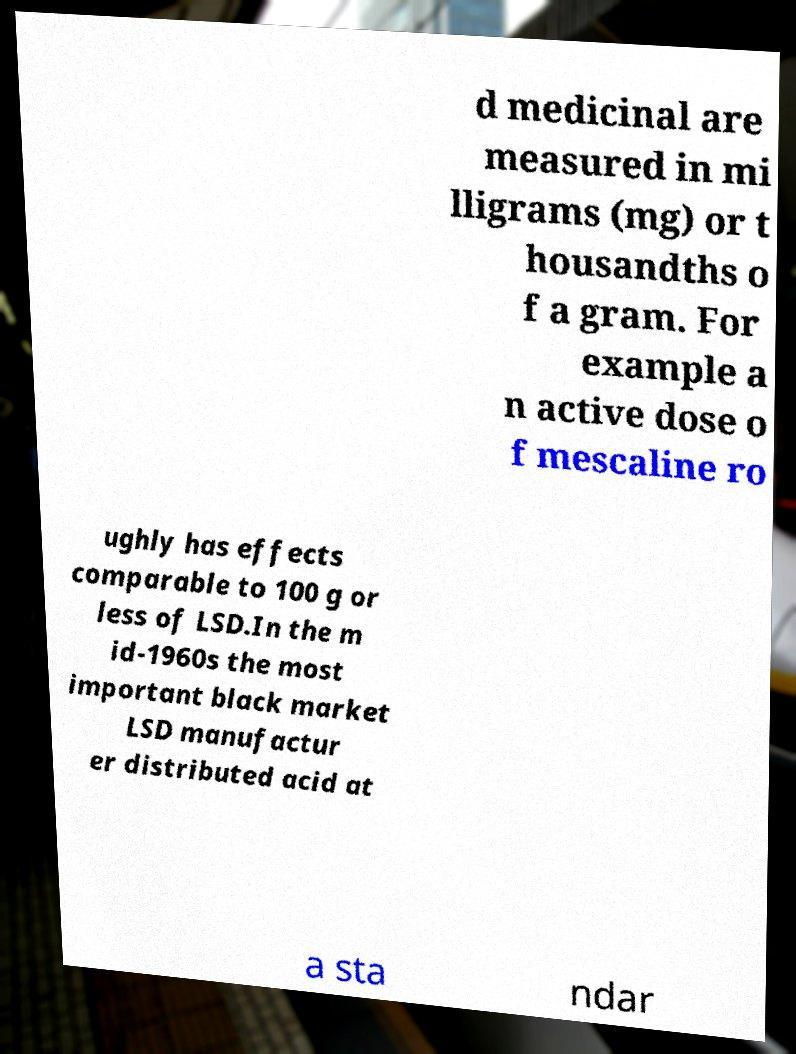Could you extract and type out the text from this image? d medicinal are measured in mi lligrams (mg) or t housandths o f a gram. For example a n active dose o f mescaline ro ughly has effects comparable to 100 g or less of LSD.In the m id-1960s the most important black market LSD manufactur er distributed acid at a sta ndar 